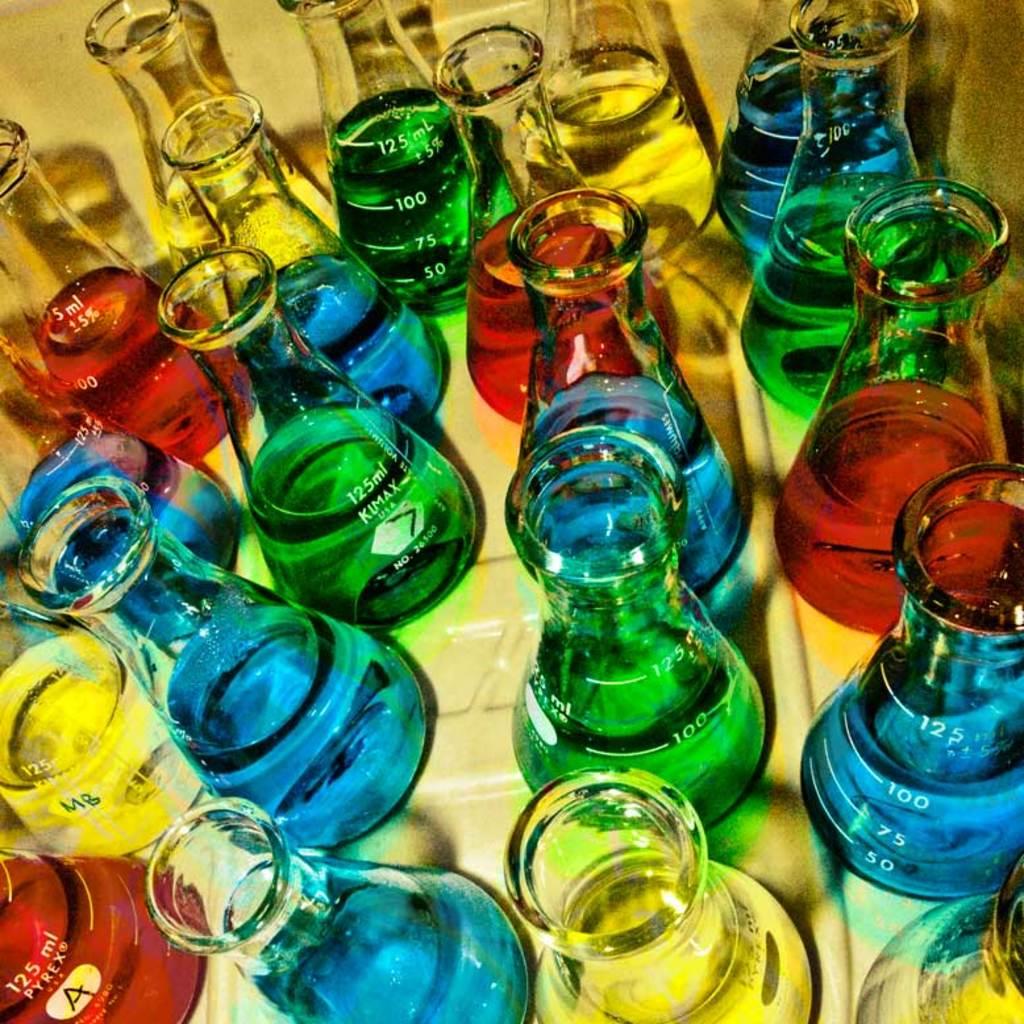How many ml's do the beakers hold?
Keep it short and to the point. 125. What letter is hand-written on the flask in the lower left corner?
Your answer should be very brief. A. 